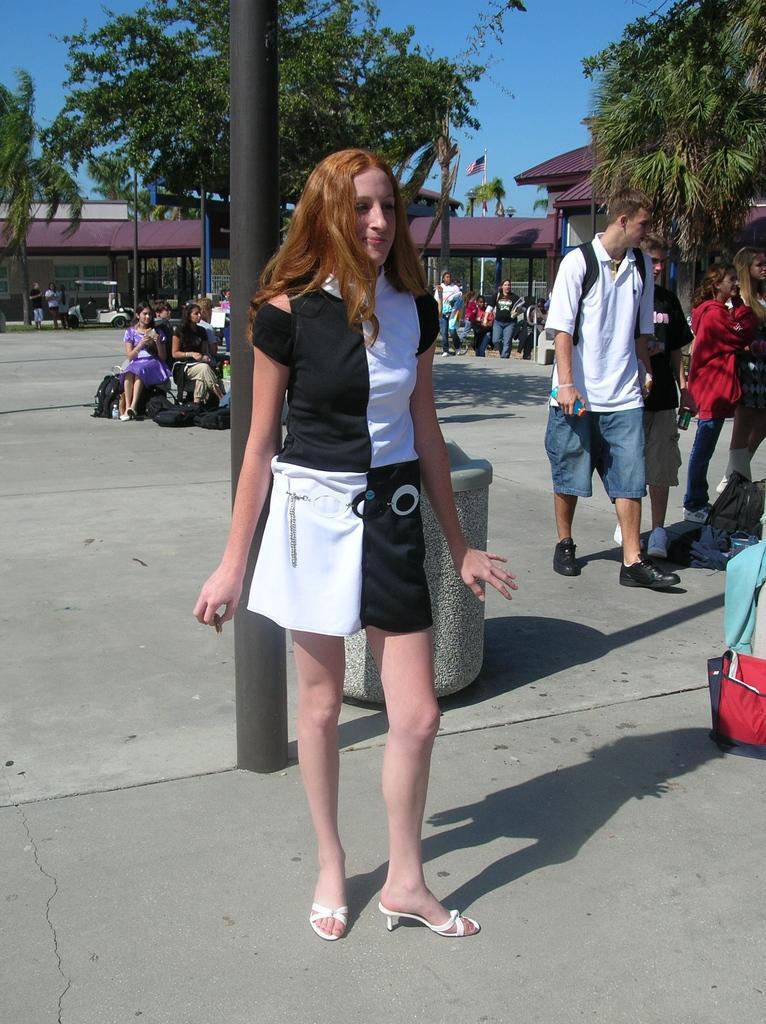In one or two sentences, can you explain what this image depicts? This image consists of a woman wearing black and white dress. At the bottom, there is road. In the background, there are trees. And there are many people in this image. 